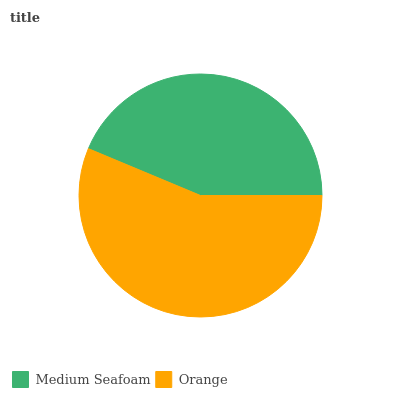Is Medium Seafoam the minimum?
Answer yes or no. Yes. Is Orange the maximum?
Answer yes or no. Yes. Is Orange the minimum?
Answer yes or no. No. Is Orange greater than Medium Seafoam?
Answer yes or no. Yes. Is Medium Seafoam less than Orange?
Answer yes or no. Yes. Is Medium Seafoam greater than Orange?
Answer yes or no. No. Is Orange less than Medium Seafoam?
Answer yes or no. No. Is Orange the high median?
Answer yes or no. Yes. Is Medium Seafoam the low median?
Answer yes or no. Yes. Is Medium Seafoam the high median?
Answer yes or no. No. Is Orange the low median?
Answer yes or no. No. 